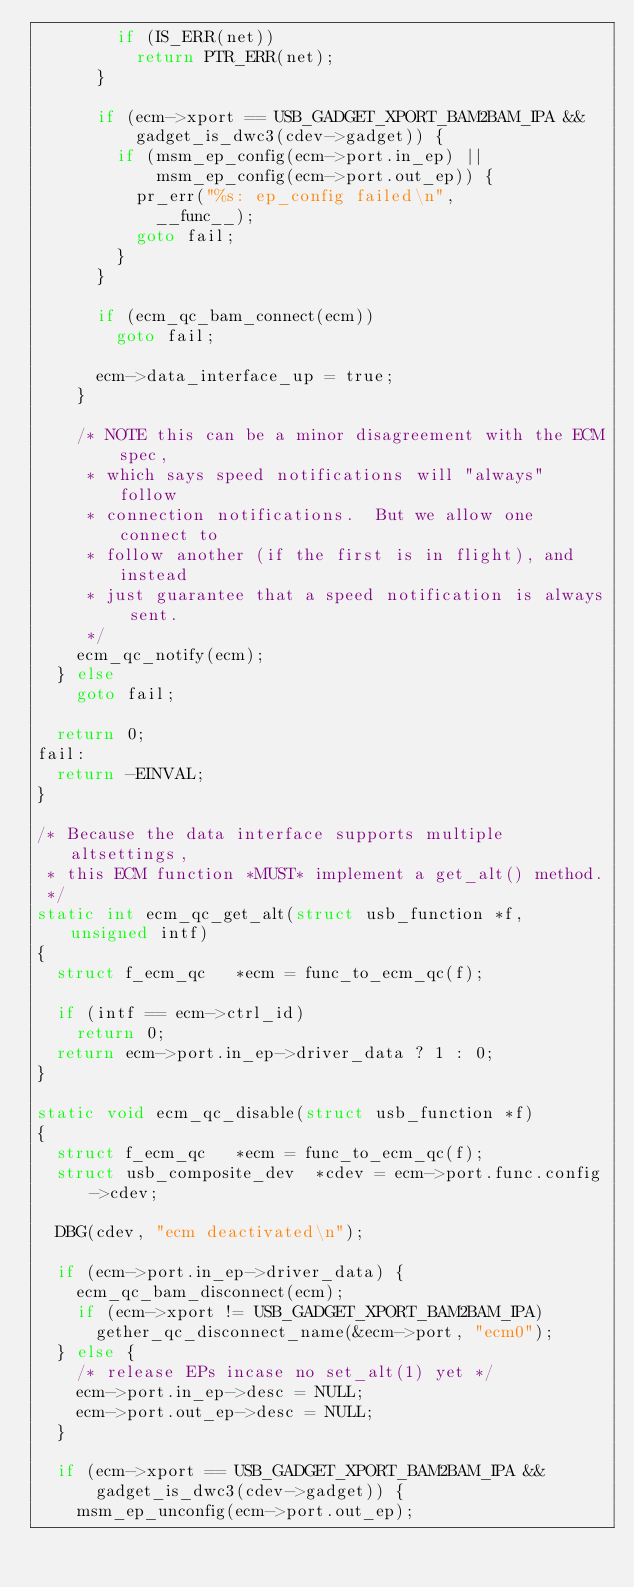<code> <loc_0><loc_0><loc_500><loc_500><_C_>				if (IS_ERR(net))
					return PTR_ERR(net);
			}

			if (ecm->xport == USB_GADGET_XPORT_BAM2BAM_IPA &&
			    gadget_is_dwc3(cdev->gadget)) {
				if (msm_ep_config(ecm->port.in_ep) ||
				    msm_ep_config(ecm->port.out_ep)) {
					pr_err("%s: ep_config failed\n",
						__func__);
					goto fail;
				}
			}

			if (ecm_qc_bam_connect(ecm))
				goto fail;

			ecm->data_interface_up = true;
		}

		/* NOTE this can be a minor disagreement with the ECM spec,
		 * which says speed notifications will "always" follow
		 * connection notifications.  But we allow one connect to
		 * follow another (if the first is in flight), and instead
		 * just guarantee that a speed notification is always sent.
		 */
		ecm_qc_notify(ecm);
	} else
		goto fail;

	return 0;
fail:
	return -EINVAL;
}

/* Because the data interface supports multiple altsettings,
 * this ECM function *MUST* implement a get_alt() method.
 */
static int ecm_qc_get_alt(struct usb_function *f, unsigned intf)
{
	struct f_ecm_qc		*ecm = func_to_ecm_qc(f);

	if (intf == ecm->ctrl_id)
		return 0;
	return ecm->port.in_ep->driver_data ? 1 : 0;
}

static void ecm_qc_disable(struct usb_function *f)
{
	struct f_ecm_qc		*ecm = func_to_ecm_qc(f);
	struct usb_composite_dev	*cdev = ecm->port.func.config->cdev;

	DBG(cdev, "ecm deactivated\n");

	if (ecm->port.in_ep->driver_data) {
		ecm_qc_bam_disconnect(ecm);
		if (ecm->xport != USB_GADGET_XPORT_BAM2BAM_IPA)
			gether_qc_disconnect_name(&ecm->port, "ecm0");
	} else {
		/* release EPs incase no set_alt(1) yet */
		ecm->port.in_ep->desc = NULL;
		ecm->port.out_ep->desc = NULL;
	}

	if (ecm->xport == USB_GADGET_XPORT_BAM2BAM_IPA &&
			gadget_is_dwc3(cdev->gadget)) {
		msm_ep_unconfig(ecm->port.out_ep);</code> 